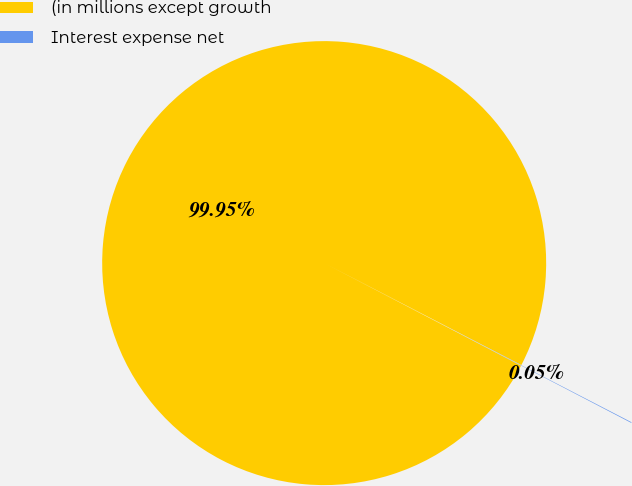Convert chart. <chart><loc_0><loc_0><loc_500><loc_500><pie_chart><fcel>(in millions except growth<fcel>Interest expense net<nl><fcel>99.95%<fcel>0.05%<nl></chart> 